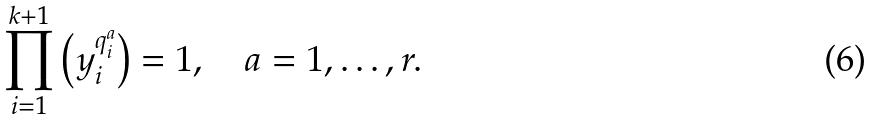<formula> <loc_0><loc_0><loc_500><loc_500>\prod _ { i = 1 } ^ { k + 1 } \left ( y _ { i } ^ { q _ { i } ^ { a } } \right ) = 1 , \quad a = 1 , \dots , r .</formula> 